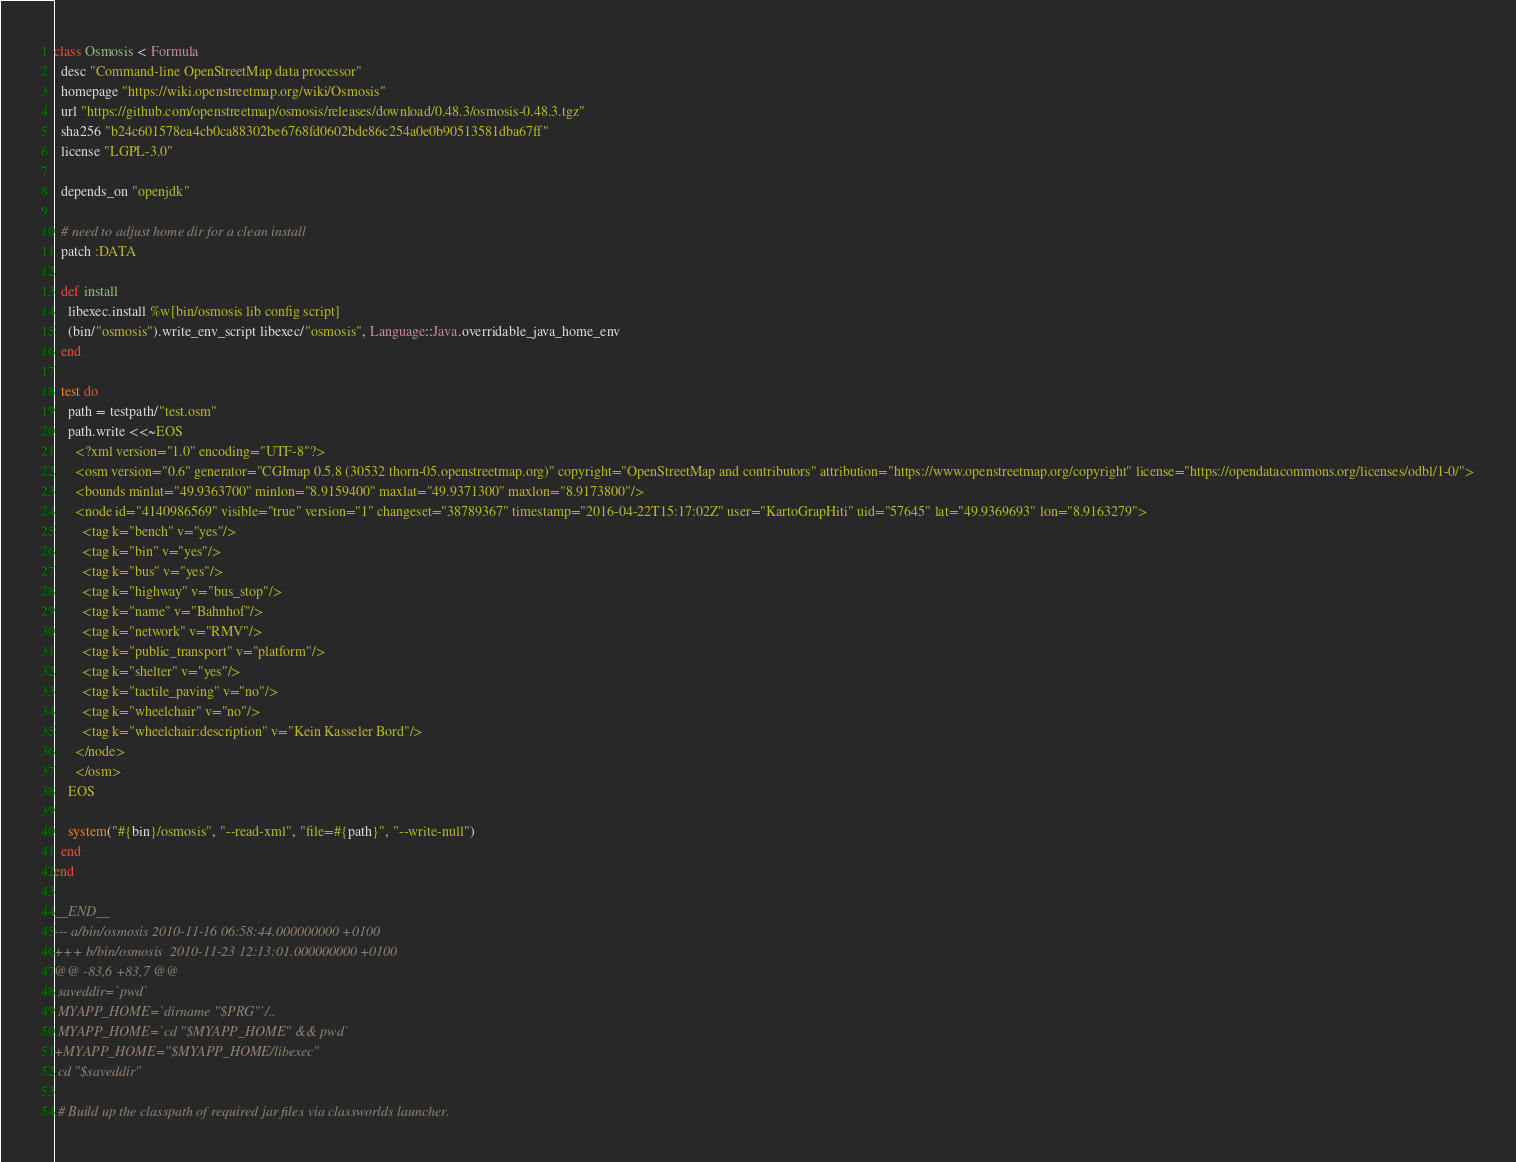Convert code to text. <code><loc_0><loc_0><loc_500><loc_500><_Ruby_>class Osmosis < Formula
  desc "Command-line OpenStreetMap data processor"
  homepage "https://wiki.openstreetmap.org/wiki/Osmosis"
  url "https://github.com/openstreetmap/osmosis/releases/download/0.48.3/osmosis-0.48.3.tgz"
  sha256 "b24c601578ea4cb0ca88302be6768fd0602bde86c254a0e0b90513581dba67ff"
  license "LGPL-3.0"

  depends_on "openjdk"

  # need to adjust home dir for a clean install
  patch :DATA

  def install
    libexec.install %w[bin/osmosis lib config script]
    (bin/"osmosis").write_env_script libexec/"osmosis", Language::Java.overridable_java_home_env
  end

  test do
    path = testpath/"test.osm"
    path.write <<~EOS
      <?xml version="1.0" encoding="UTF-8"?>
      <osm version="0.6" generator="CGImap 0.5.8 (30532 thorn-05.openstreetmap.org)" copyright="OpenStreetMap and contributors" attribution="https://www.openstreetmap.org/copyright" license="https://opendatacommons.org/licenses/odbl/1-0/">
      <bounds minlat="49.9363700" minlon="8.9159400" maxlat="49.9371300" maxlon="8.9173800"/>
      <node id="4140986569" visible="true" version="1" changeset="38789367" timestamp="2016-04-22T15:17:02Z" user="KartoGrapHiti" uid="57645" lat="49.9369693" lon="8.9163279">
        <tag k="bench" v="yes"/>
        <tag k="bin" v="yes"/>
        <tag k="bus" v="yes"/>
        <tag k="highway" v="bus_stop"/>
        <tag k="name" v="Bahnhof"/>
        <tag k="network" v="RMV"/>
        <tag k="public_transport" v="platform"/>
        <tag k="shelter" v="yes"/>
        <tag k="tactile_paving" v="no"/>
        <tag k="wheelchair" v="no"/>
        <tag k="wheelchair:description" v="Kein Kasseler Bord"/>
      </node>
      </osm>
    EOS

    system("#{bin}/osmosis", "--read-xml", "file=#{path}", "--write-null")
  end
end

__END__
--- a/bin/osmosis 2010-11-16 06:58:44.000000000 +0100
+++ b/bin/osmosis  2010-11-23 12:13:01.000000000 +0100
@@ -83,6 +83,7 @@
 saveddir=`pwd`
 MYAPP_HOME=`dirname "$PRG"`/..
 MYAPP_HOME=`cd "$MYAPP_HOME" && pwd`
+MYAPP_HOME="$MYAPP_HOME/libexec"
 cd "$saveddir"

 # Build up the classpath of required jar files via classworlds launcher.
</code> 